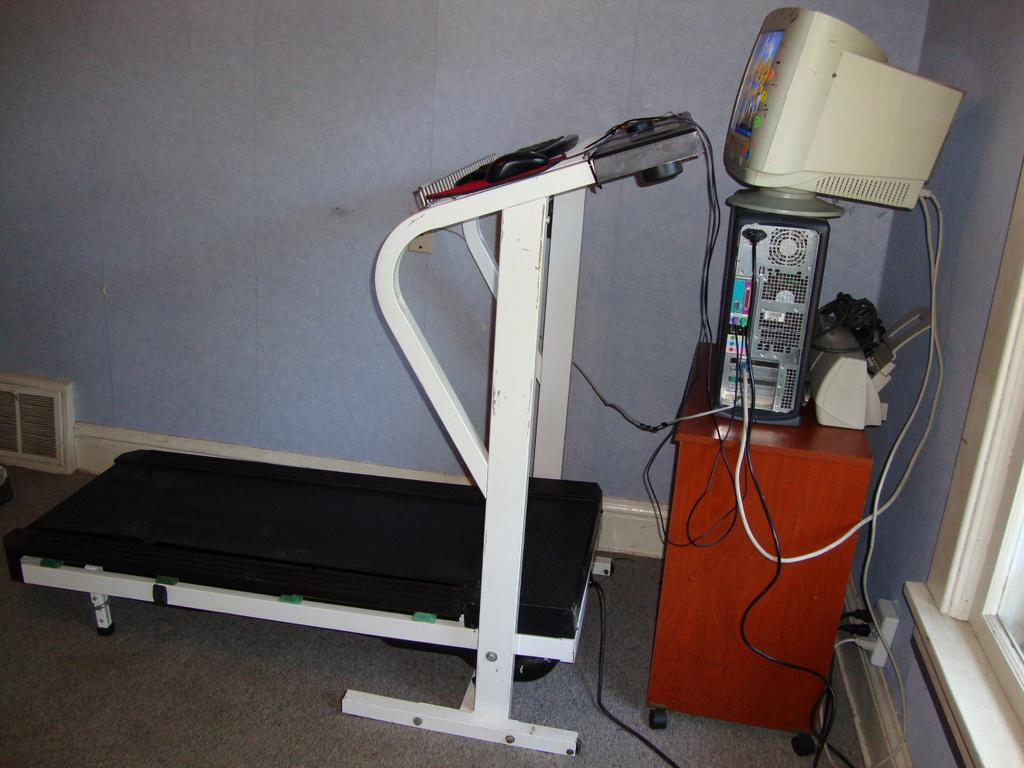What exercise equipment is present in the image? There is a treadmill in the image. What is located at the top of the image? There is a desktop at the top of the image. What computer component is in the middle of the image? There is a CPU in the middle of the image. What piece of furniture is in the middle of the image? There is a table in the middle of the image. What can be seen on the right side of the image? There is a window on the right side of the image. How many soda is being served on the plate in the image? There is no soda or plate present in the image. What are the hands doing in the image? There are no hands visible in the image. 